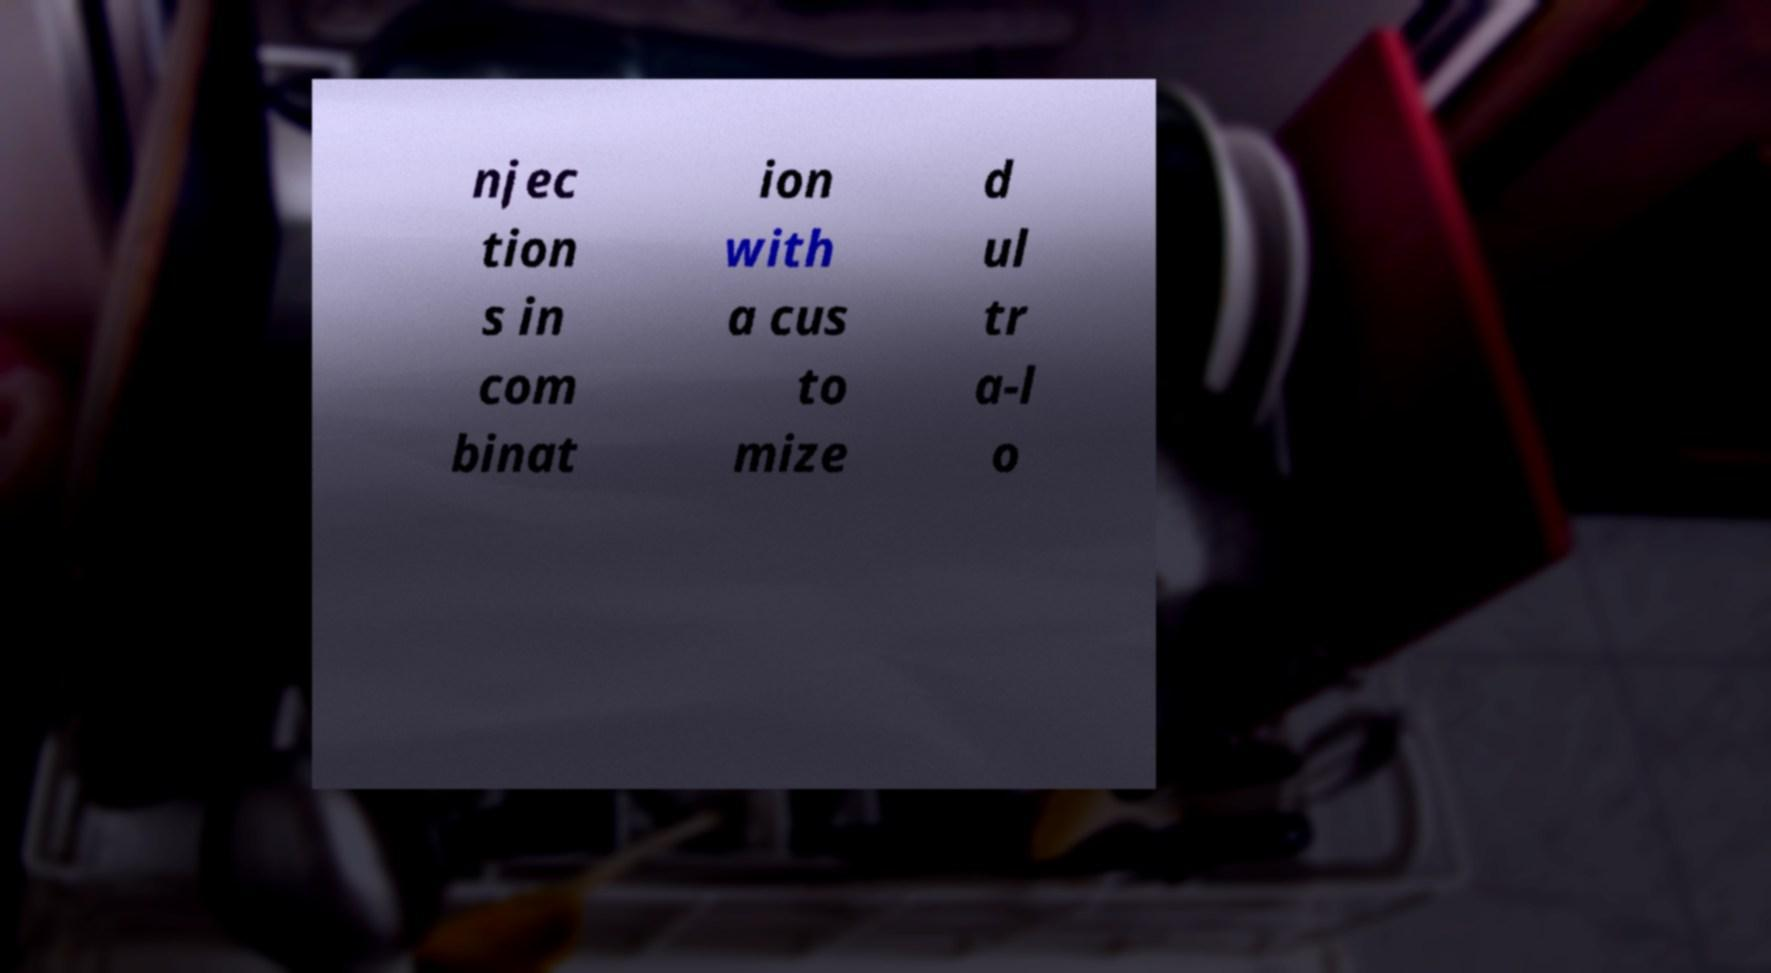Could you extract and type out the text from this image? njec tion s in com binat ion with a cus to mize d ul tr a-l o 